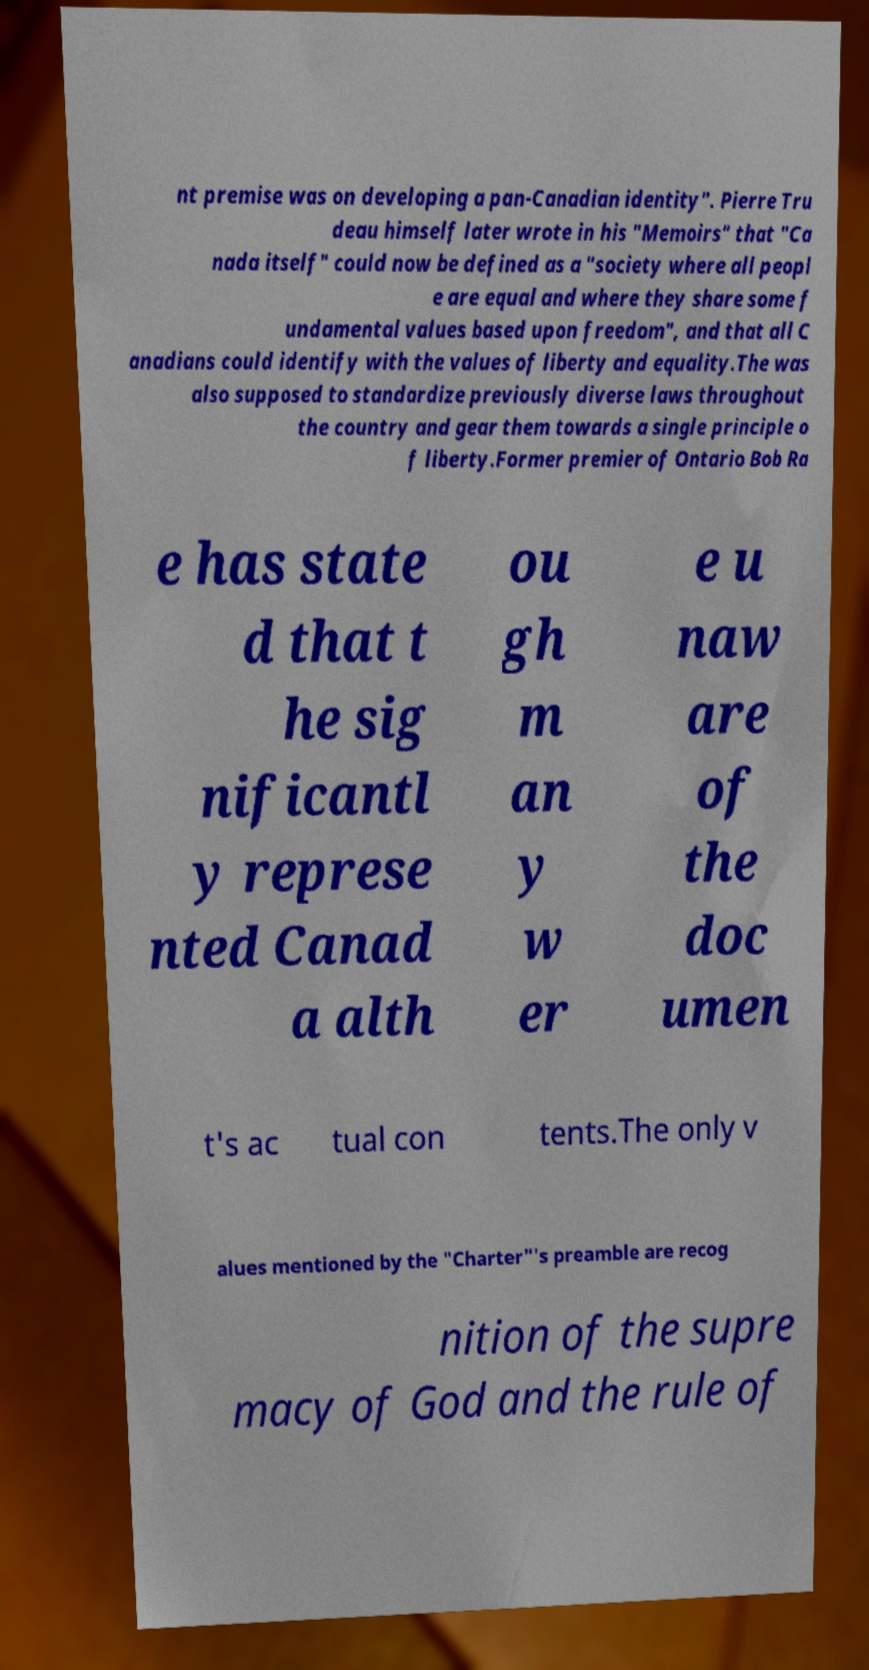Please identify and transcribe the text found in this image. nt premise was on developing a pan-Canadian identity". Pierre Tru deau himself later wrote in his "Memoirs" that "Ca nada itself" could now be defined as a "society where all peopl e are equal and where they share some f undamental values based upon freedom", and that all C anadians could identify with the values of liberty and equality.The was also supposed to standardize previously diverse laws throughout the country and gear them towards a single principle o f liberty.Former premier of Ontario Bob Ra e has state d that t he sig nificantl y represe nted Canad a alth ou gh m an y w er e u naw are of the doc umen t's ac tual con tents.The only v alues mentioned by the "Charter"'s preamble are recog nition of the supre macy of God and the rule of 